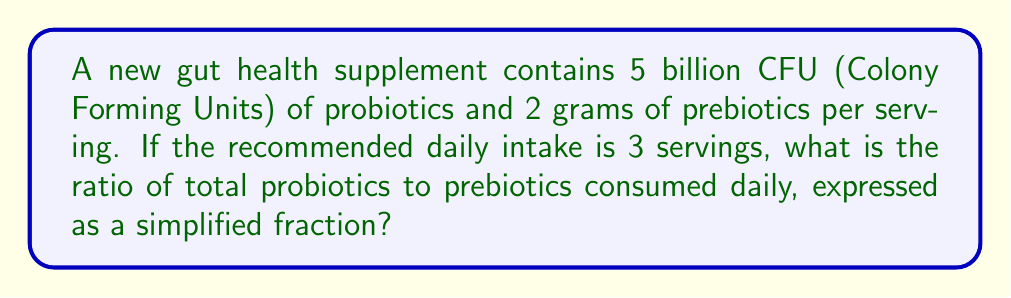Could you help me with this problem? To solve this problem, let's follow these steps:

1. Calculate the total amount of probiotics per day:
   $5 \text{ billion CFU} \times 3 \text{ servings} = 15 \text{ billion CFU}$

2. Calculate the total amount of prebiotics per day:
   $2 \text{ grams} \times 3 \text{ servings} = 6 \text{ grams}$

3. Set up the ratio of probiotics to prebiotics:
   $\frac{15 \text{ billion CFU}}{6 \text{ grams}}$

4. Simplify the ratio by dividing both the numerator and denominator by their greatest common factor (GCF):
   The GCF of 15 and 6 is 3.
   
   $$\frac{15 \text{ billion CFU}}{6 \text{ grams}} = \frac{15 \div 3 \text{ billion CFU}}{6 \div 3 \text{ grams}} = \frac{5 \text{ billion CFU}}{2 \text{ grams}}$$

5. The final simplified ratio is 5:2, which can be expressed as a fraction $\frac{5}{2}$.
Answer: $\frac{5}{2}$ 